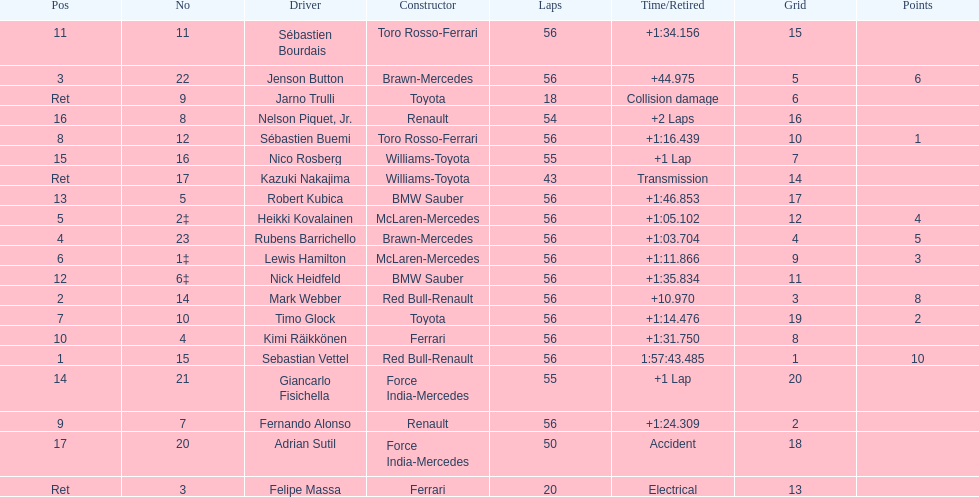What driver was last on the list? Jarno Trulli. 